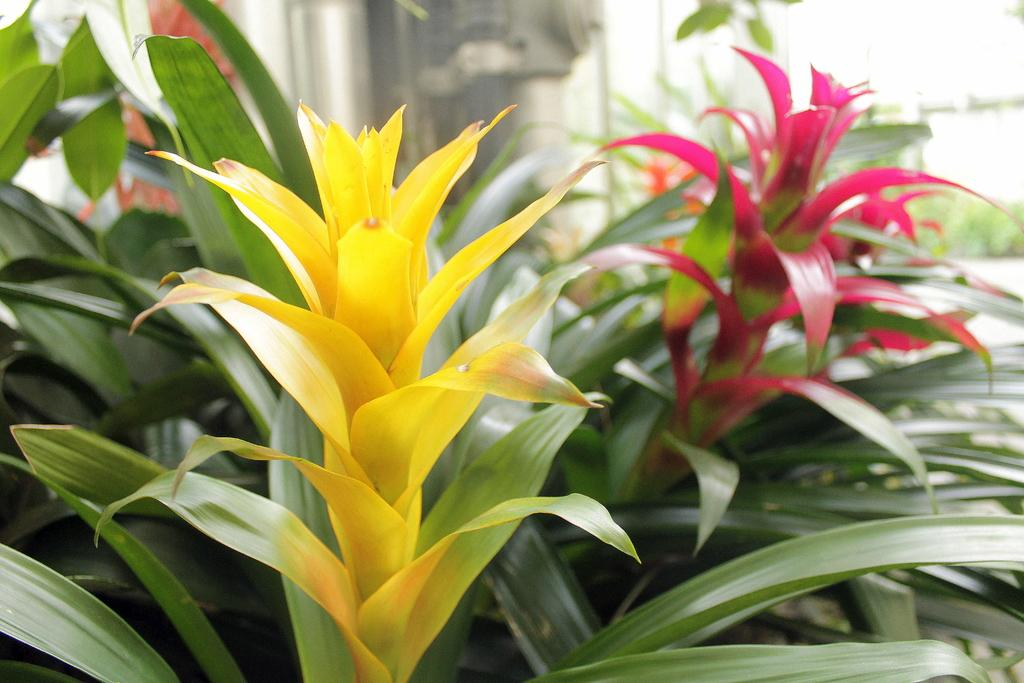What type of plants can be seen in the image? There are plants with flowers in the image. Can you describe the background of the image? The background of the image is blurred. What type of brick is used to build the doctor's office in the image? There is no doctor's office or brick present in the image; it features plants with flowers and a blurred background. 